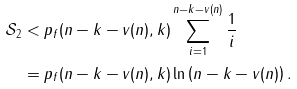Convert formula to latex. <formula><loc_0><loc_0><loc_500><loc_500>\mathcal { S } _ { 2 } & < p _ { f } ( n - k - v ( n ) , k ) \sum _ { i = 1 } ^ { n - k - v ( n ) } \frac { 1 } { i } \\ & = p _ { f } ( n - k - v ( n ) , k ) \ln \left ( n - k - v ( n ) \right ) .</formula> 